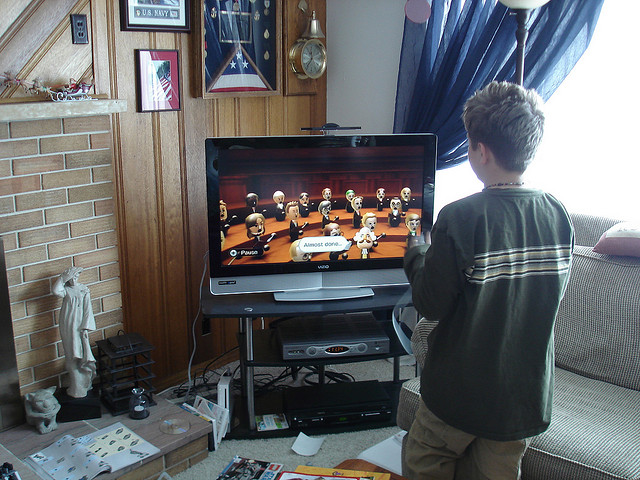Please extract the text content from this image. NAVY US 